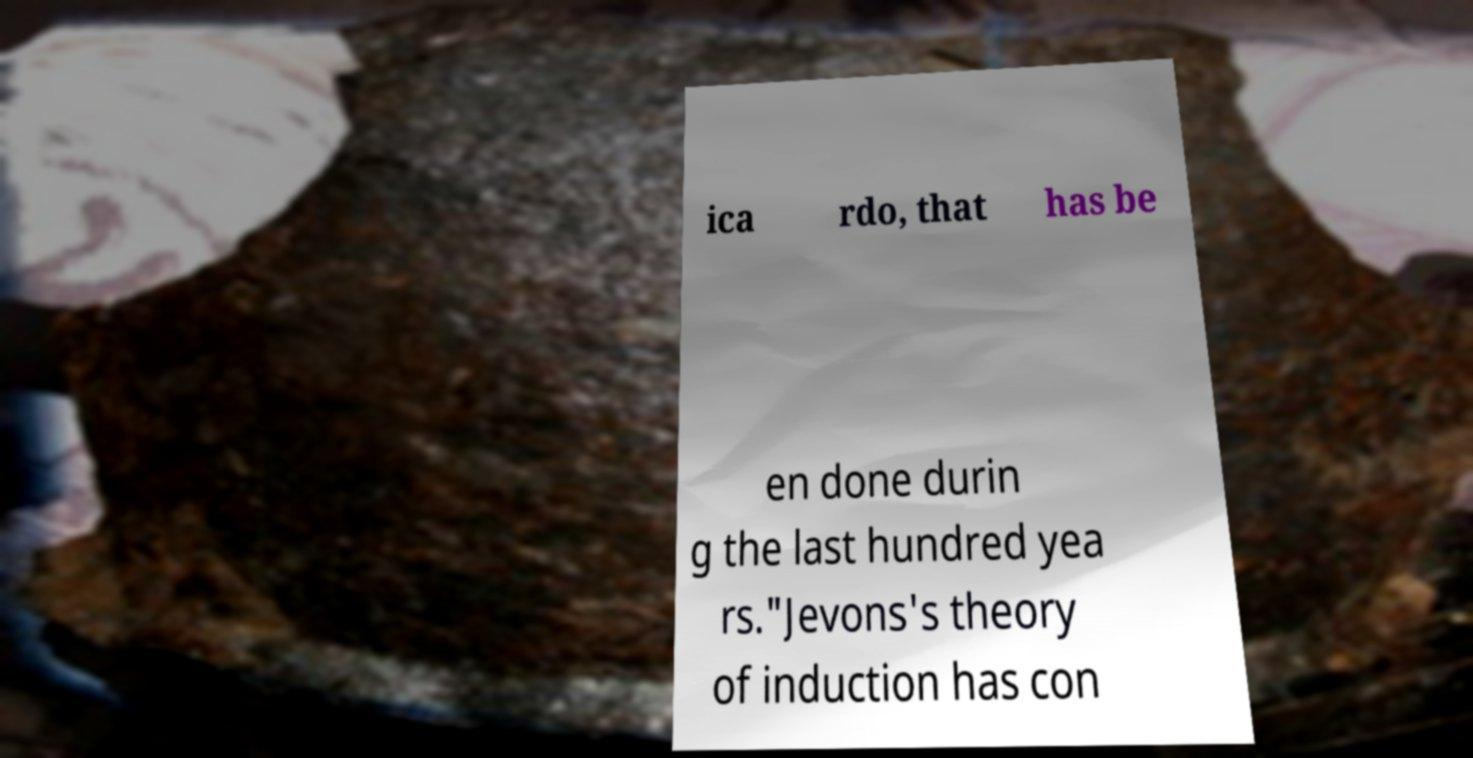Can you read and provide the text displayed in the image?This photo seems to have some interesting text. Can you extract and type it out for me? ica rdo, that has be en done durin g the last hundred yea rs."Jevons's theory of induction has con 